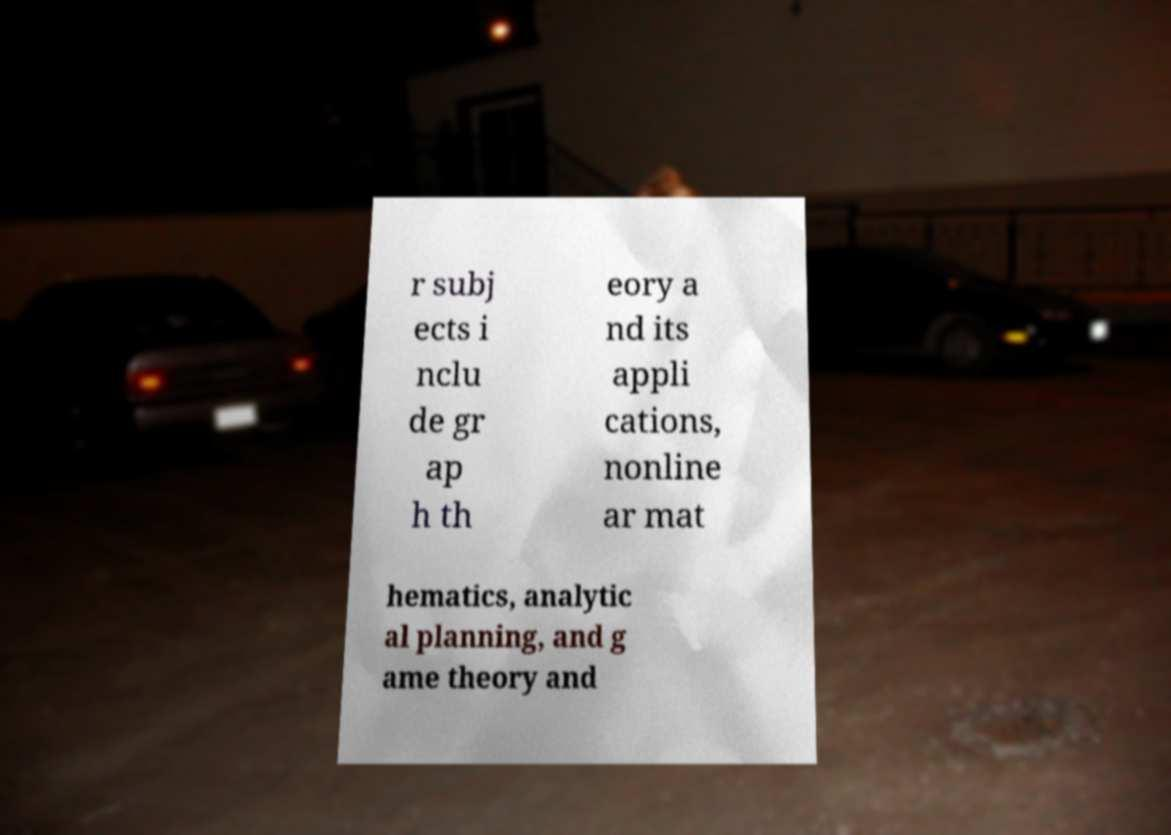Can you read and provide the text displayed in the image?This photo seems to have some interesting text. Can you extract and type it out for me? r subj ects i nclu de gr ap h th eory a nd its appli cations, nonline ar mat hematics, analytic al planning, and g ame theory and 